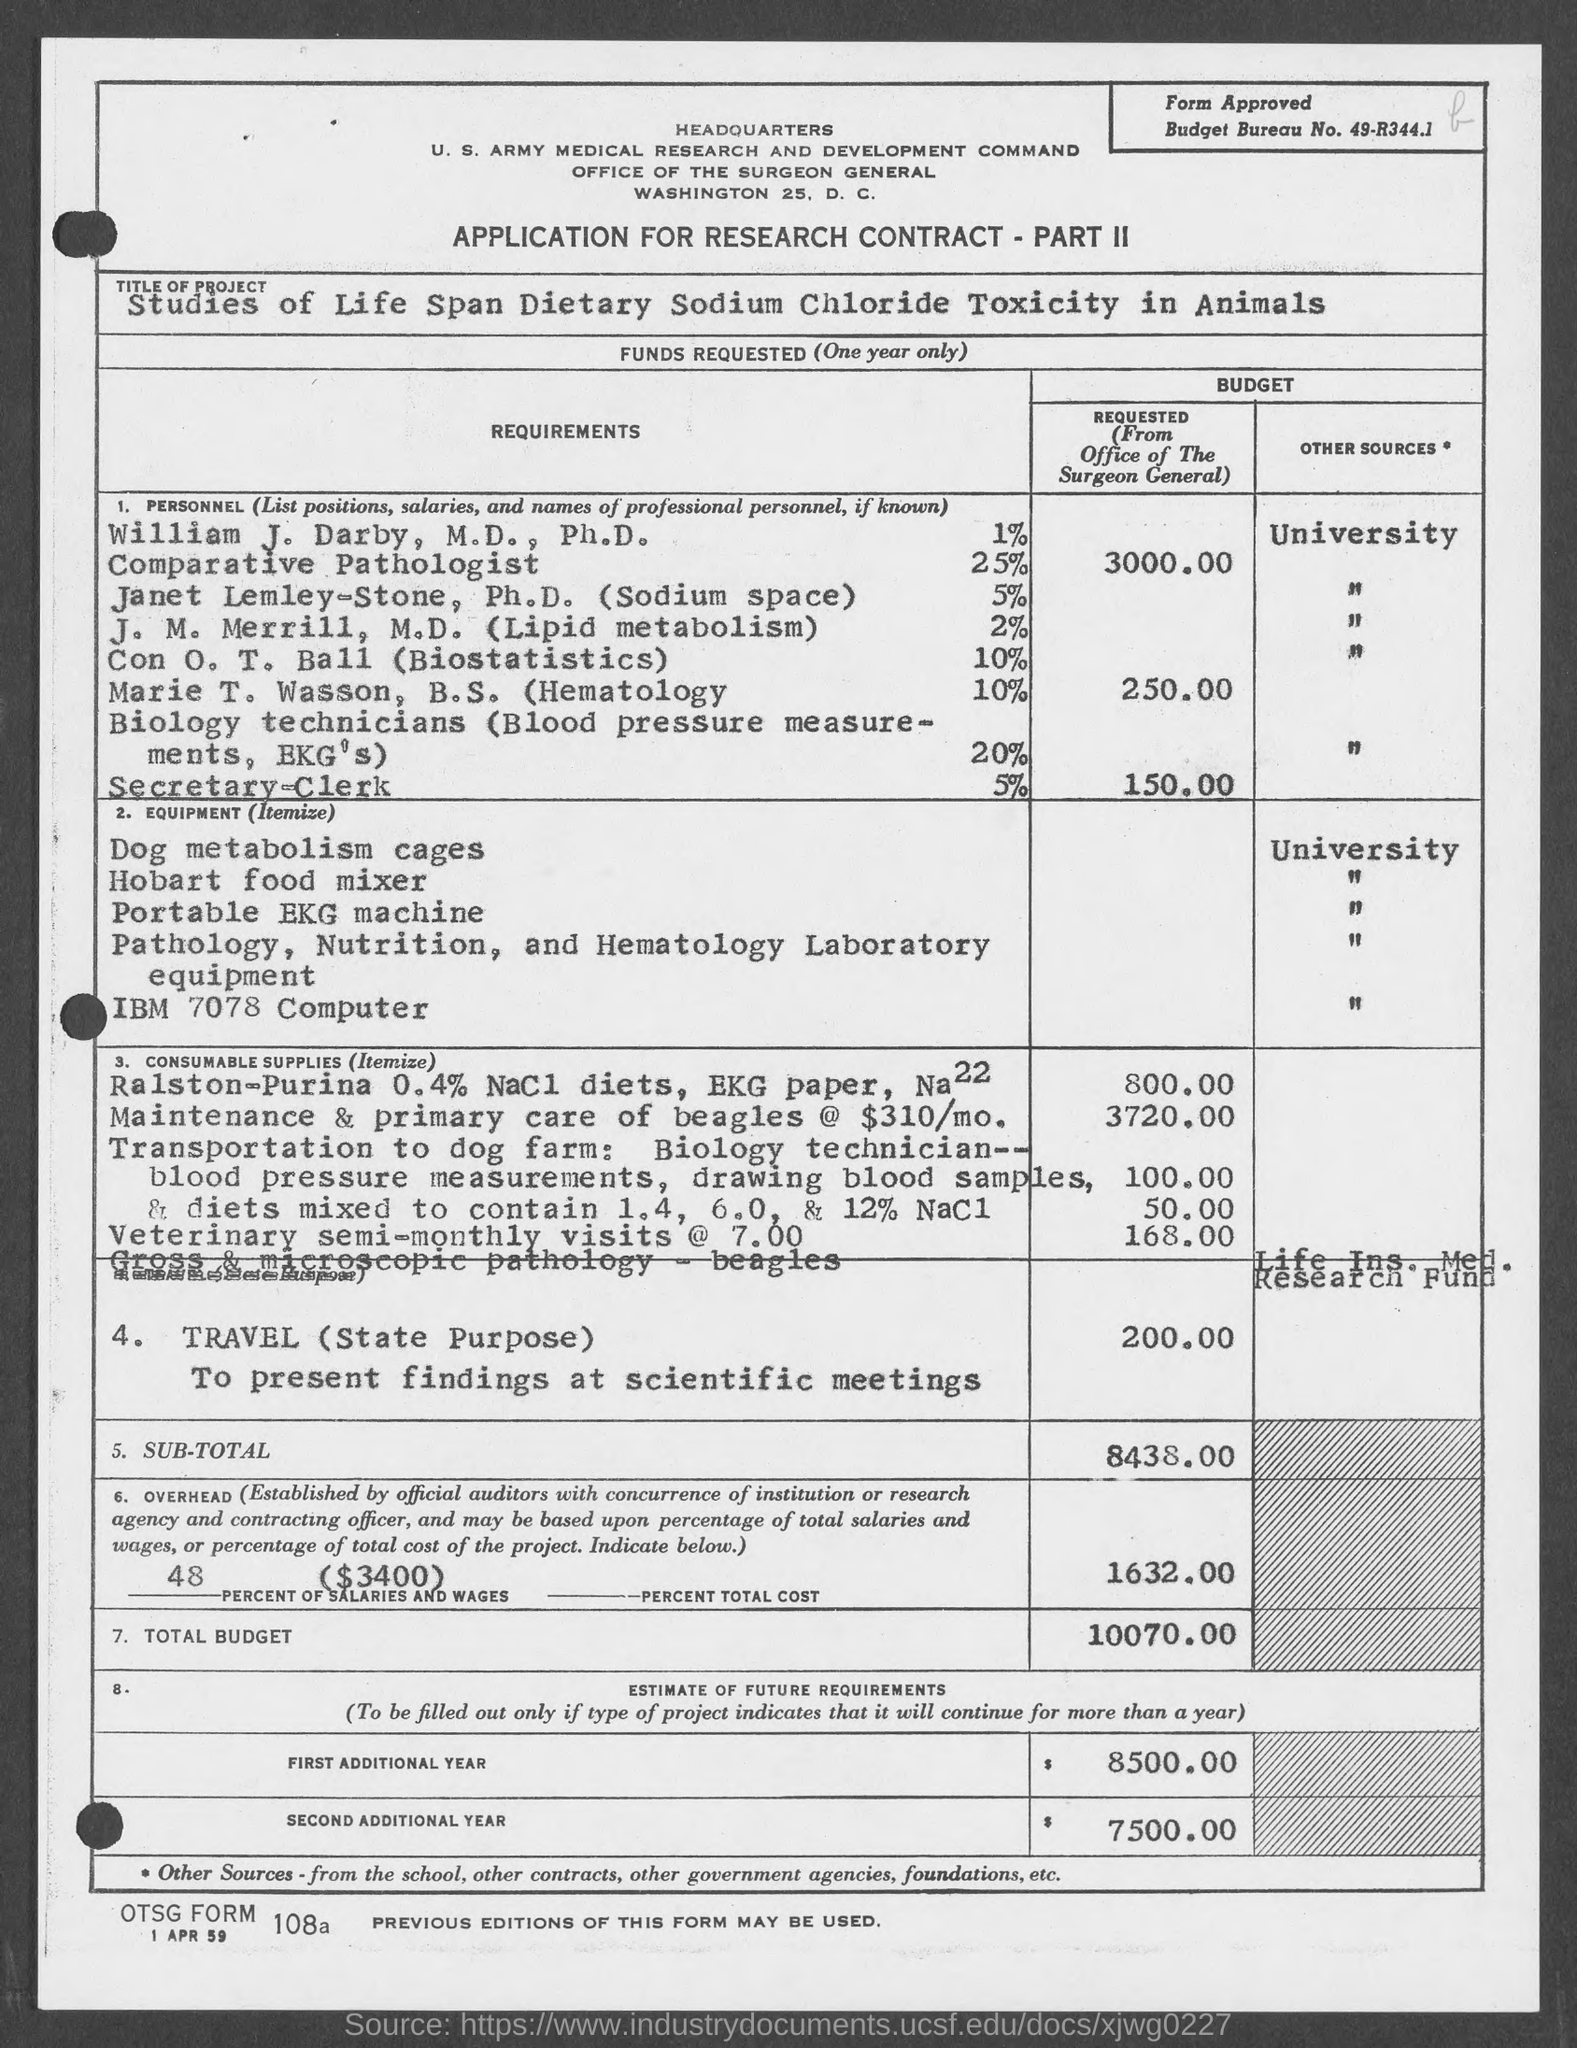What is the budget bureau no.?
Make the answer very short. 49-R344.1. 